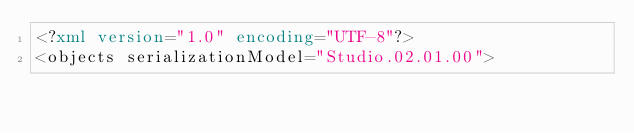<code> <loc_0><loc_0><loc_500><loc_500><_XML_><?xml version="1.0" encoding="UTF-8"?>
<objects serializationModel="Studio.02.01.00"></code> 